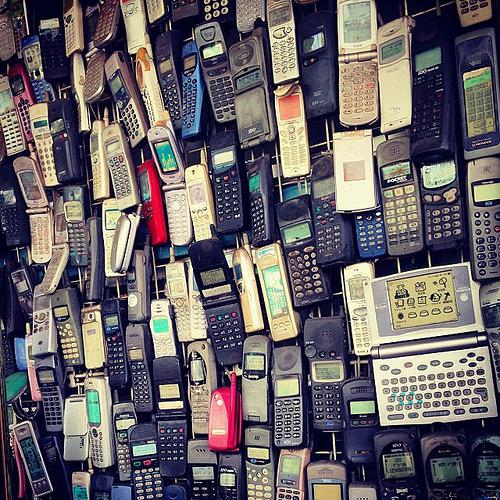Question: what is on the wall?
Choices:
A. Electronics.
B. Pictures.
C. Paintings.
D. Light switches.
Answer with the letter. Answer: A Question: where is the PDA?
Choices:
A. Near the right bottom.
B. Next to the tree.
C. On the guardrail next to the road.
D. On the brick wall.
Answer with the letter. Answer: A Question: what are on all the items?
Choices:
A. Screens.
B. Blue Tarps.
C. Chains.
D. Locks.
Answer with the letter. Answer: A Question: where are the items?
Choices:
A. Propped up.
B. Hanging.
C. Fallen over.
D. Under the tent.
Answer with the letter. Answer: B Question: how many red phones?
Choices:
A. 2.
B. 3.
C. 4.
D. 1.
Answer with the letter. Answer: D 